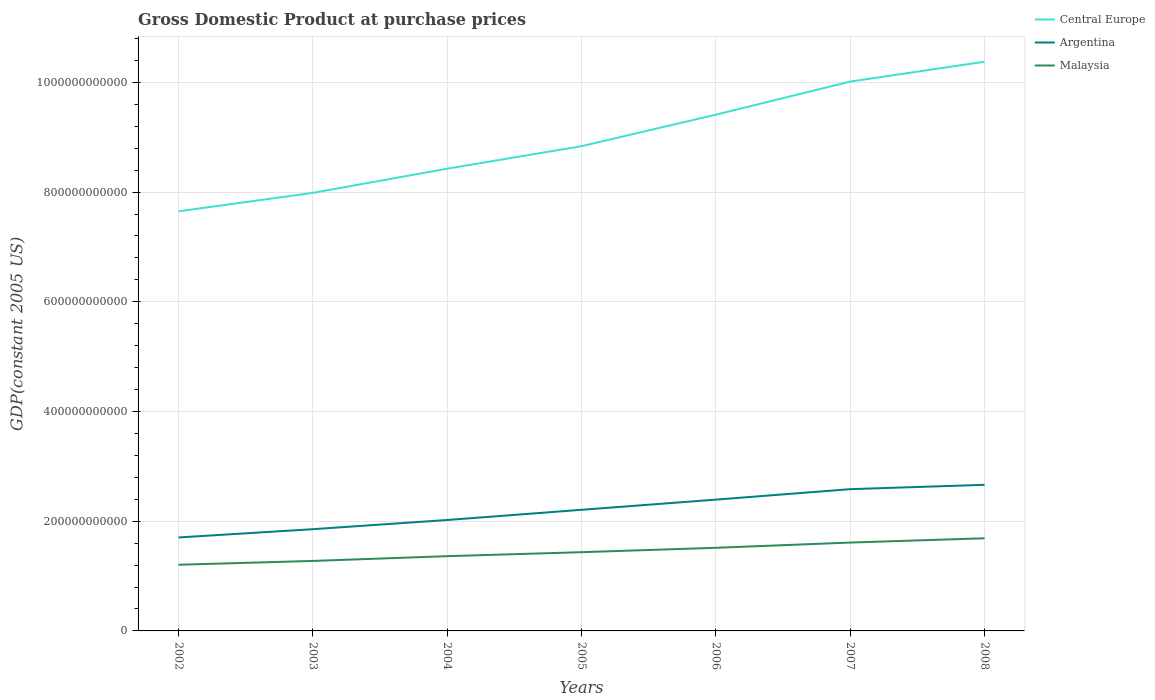Does the line corresponding to Malaysia intersect with the line corresponding to Central Europe?
Your response must be concise. No. Is the number of lines equal to the number of legend labels?
Offer a terse response. Yes. Across all years, what is the maximum GDP at purchase prices in Malaysia?
Give a very brief answer. 1.21e+11. What is the total GDP at purchase prices in Malaysia in the graph?
Your answer should be very brief. -9.55e+09. What is the difference between the highest and the second highest GDP at purchase prices in Malaysia?
Offer a terse response. 4.83e+1. What is the difference between the highest and the lowest GDP at purchase prices in Malaysia?
Your response must be concise. 3. Is the GDP at purchase prices in Argentina strictly greater than the GDP at purchase prices in Malaysia over the years?
Provide a short and direct response. No. How many lines are there?
Your response must be concise. 3. How many years are there in the graph?
Keep it short and to the point. 7. What is the difference between two consecutive major ticks on the Y-axis?
Ensure brevity in your answer.  2.00e+11. Are the values on the major ticks of Y-axis written in scientific E-notation?
Provide a short and direct response. No. How many legend labels are there?
Your answer should be very brief. 3. How are the legend labels stacked?
Give a very brief answer. Vertical. What is the title of the graph?
Offer a terse response. Gross Domestic Product at purchase prices. What is the label or title of the X-axis?
Ensure brevity in your answer.  Years. What is the label or title of the Y-axis?
Provide a short and direct response. GDP(constant 2005 US). What is the GDP(constant 2005 US) of Central Europe in 2002?
Make the answer very short. 7.65e+11. What is the GDP(constant 2005 US) of Argentina in 2002?
Your answer should be very brief. 1.70e+11. What is the GDP(constant 2005 US) of Malaysia in 2002?
Provide a succinct answer. 1.21e+11. What is the GDP(constant 2005 US) of Central Europe in 2003?
Provide a short and direct response. 7.99e+11. What is the GDP(constant 2005 US) of Argentina in 2003?
Your answer should be compact. 1.85e+11. What is the GDP(constant 2005 US) of Malaysia in 2003?
Your answer should be very brief. 1.28e+11. What is the GDP(constant 2005 US) in Central Europe in 2004?
Keep it short and to the point. 8.43e+11. What is the GDP(constant 2005 US) of Argentina in 2004?
Ensure brevity in your answer.  2.02e+11. What is the GDP(constant 2005 US) of Malaysia in 2004?
Your response must be concise. 1.36e+11. What is the GDP(constant 2005 US) of Central Europe in 2005?
Offer a very short reply. 8.84e+11. What is the GDP(constant 2005 US) in Argentina in 2005?
Give a very brief answer. 2.21e+11. What is the GDP(constant 2005 US) of Malaysia in 2005?
Your answer should be compact. 1.44e+11. What is the GDP(constant 2005 US) of Central Europe in 2006?
Give a very brief answer. 9.41e+11. What is the GDP(constant 2005 US) in Argentina in 2006?
Your answer should be very brief. 2.39e+11. What is the GDP(constant 2005 US) of Malaysia in 2006?
Provide a short and direct response. 1.52e+11. What is the GDP(constant 2005 US) of Central Europe in 2007?
Keep it short and to the point. 1.00e+12. What is the GDP(constant 2005 US) of Argentina in 2007?
Keep it short and to the point. 2.58e+11. What is the GDP(constant 2005 US) in Malaysia in 2007?
Provide a succinct answer. 1.61e+11. What is the GDP(constant 2005 US) in Central Europe in 2008?
Offer a terse response. 1.04e+12. What is the GDP(constant 2005 US) in Argentina in 2008?
Offer a very short reply. 2.66e+11. What is the GDP(constant 2005 US) of Malaysia in 2008?
Keep it short and to the point. 1.69e+11. Across all years, what is the maximum GDP(constant 2005 US) in Central Europe?
Give a very brief answer. 1.04e+12. Across all years, what is the maximum GDP(constant 2005 US) in Argentina?
Your answer should be very brief. 2.66e+11. Across all years, what is the maximum GDP(constant 2005 US) of Malaysia?
Make the answer very short. 1.69e+11. Across all years, what is the minimum GDP(constant 2005 US) of Central Europe?
Provide a succinct answer. 7.65e+11. Across all years, what is the minimum GDP(constant 2005 US) of Argentina?
Your answer should be compact. 1.70e+11. Across all years, what is the minimum GDP(constant 2005 US) in Malaysia?
Provide a short and direct response. 1.21e+11. What is the total GDP(constant 2005 US) of Central Europe in the graph?
Give a very brief answer. 6.27e+12. What is the total GDP(constant 2005 US) in Argentina in the graph?
Your response must be concise. 1.54e+12. What is the total GDP(constant 2005 US) in Malaysia in the graph?
Make the answer very short. 1.01e+12. What is the difference between the GDP(constant 2005 US) in Central Europe in 2002 and that in 2003?
Ensure brevity in your answer.  -3.36e+1. What is the difference between the GDP(constant 2005 US) in Argentina in 2002 and that in 2003?
Ensure brevity in your answer.  -1.51e+1. What is the difference between the GDP(constant 2005 US) in Malaysia in 2002 and that in 2003?
Give a very brief answer. -6.98e+09. What is the difference between the GDP(constant 2005 US) in Central Europe in 2002 and that in 2004?
Your response must be concise. -7.77e+1. What is the difference between the GDP(constant 2005 US) of Argentina in 2002 and that in 2004?
Offer a terse response. -3.18e+1. What is the difference between the GDP(constant 2005 US) in Malaysia in 2002 and that in 2004?
Your answer should be very brief. -1.56e+1. What is the difference between the GDP(constant 2005 US) in Central Europe in 2002 and that in 2005?
Provide a short and direct response. -1.19e+11. What is the difference between the GDP(constant 2005 US) of Argentina in 2002 and that in 2005?
Make the answer very short. -5.04e+1. What is the difference between the GDP(constant 2005 US) of Malaysia in 2002 and that in 2005?
Your answer should be very brief. -2.29e+1. What is the difference between the GDP(constant 2005 US) in Central Europe in 2002 and that in 2006?
Provide a short and direct response. -1.76e+11. What is the difference between the GDP(constant 2005 US) of Argentina in 2002 and that in 2006?
Your answer should be compact. -6.90e+1. What is the difference between the GDP(constant 2005 US) of Malaysia in 2002 and that in 2006?
Provide a succinct answer. -3.09e+1. What is the difference between the GDP(constant 2005 US) in Central Europe in 2002 and that in 2007?
Provide a succinct answer. -2.37e+11. What is the difference between the GDP(constant 2005 US) in Argentina in 2002 and that in 2007?
Your answer should be very brief. -8.80e+1. What is the difference between the GDP(constant 2005 US) in Malaysia in 2002 and that in 2007?
Provide a succinct answer. -4.05e+1. What is the difference between the GDP(constant 2005 US) in Central Europe in 2002 and that in 2008?
Your response must be concise. -2.73e+11. What is the difference between the GDP(constant 2005 US) of Argentina in 2002 and that in 2008?
Your answer should be compact. -9.60e+1. What is the difference between the GDP(constant 2005 US) in Malaysia in 2002 and that in 2008?
Provide a short and direct response. -4.83e+1. What is the difference between the GDP(constant 2005 US) in Central Europe in 2003 and that in 2004?
Offer a terse response. -4.41e+1. What is the difference between the GDP(constant 2005 US) in Argentina in 2003 and that in 2004?
Make the answer very short. -1.67e+1. What is the difference between the GDP(constant 2005 US) in Malaysia in 2003 and that in 2004?
Provide a short and direct response. -8.66e+09. What is the difference between the GDP(constant 2005 US) of Central Europe in 2003 and that in 2005?
Your response must be concise. -8.51e+1. What is the difference between the GDP(constant 2005 US) in Argentina in 2003 and that in 2005?
Give a very brief answer. -3.53e+1. What is the difference between the GDP(constant 2005 US) of Malaysia in 2003 and that in 2005?
Offer a very short reply. -1.59e+1. What is the difference between the GDP(constant 2005 US) in Central Europe in 2003 and that in 2006?
Ensure brevity in your answer.  -1.43e+11. What is the difference between the GDP(constant 2005 US) in Argentina in 2003 and that in 2006?
Offer a terse response. -5.39e+1. What is the difference between the GDP(constant 2005 US) in Malaysia in 2003 and that in 2006?
Ensure brevity in your answer.  -2.39e+1. What is the difference between the GDP(constant 2005 US) of Central Europe in 2003 and that in 2007?
Offer a very short reply. -2.03e+11. What is the difference between the GDP(constant 2005 US) in Argentina in 2003 and that in 2007?
Give a very brief answer. -7.30e+1. What is the difference between the GDP(constant 2005 US) of Malaysia in 2003 and that in 2007?
Offer a terse response. -3.35e+1. What is the difference between the GDP(constant 2005 US) of Central Europe in 2003 and that in 2008?
Ensure brevity in your answer.  -2.39e+11. What is the difference between the GDP(constant 2005 US) in Argentina in 2003 and that in 2008?
Your answer should be compact. -8.09e+1. What is the difference between the GDP(constant 2005 US) in Malaysia in 2003 and that in 2008?
Your answer should be very brief. -4.13e+1. What is the difference between the GDP(constant 2005 US) of Central Europe in 2004 and that in 2005?
Your answer should be compact. -4.10e+1. What is the difference between the GDP(constant 2005 US) of Argentina in 2004 and that in 2005?
Your answer should be very brief. -1.86e+1. What is the difference between the GDP(constant 2005 US) of Malaysia in 2004 and that in 2005?
Provide a succinct answer. -7.27e+09. What is the difference between the GDP(constant 2005 US) in Central Europe in 2004 and that in 2006?
Make the answer very short. -9.85e+1. What is the difference between the GDP(constant 2005 US) of Argentina in 2004 and that in 2006?
Provide a short and direct response. -3.72e+1. What is the difference between the GDP(constant 2005 US) of Malaysia in 2004 and that in 2006?
Provide a succinct answer. -1.53e+1. What is the difference between the GDP(constant 2005 US) in Central Europe in 2004 and that in 2007?
Your answer should be very brief. -1.59e+11. What is the difference between the GDP(constant 2005 US) in Argentina in 2004 and that in 2007?
Ensure brevity in your answer.  -5.62e+1. What is the difference between the GDP(constant 2005 US) of Malaysia in 2004 and that in 2007?
Your response must be concise. -2.48e+1. What is the difference between the GDP(constant 2005 US) in Central Europe in 2004 and that in 2008?
Offer a very short reply. -1.95e+11. What is the difference between the GDP(constant 2005 US) of Argentina in 2004 and that in 2008?
Offer a very short reply. -6.42e+1. What is the difference between the GDP(constant 2005 US) of Malaysia in 2004 and that in 2008?
Your response must be concise. -3.26e+1. What is the difference between the GDP(constant 2005 US) in Central Europe in 2005 and that in 2006?
Provide a succinct answer. -5.74e+1. What is the difference between the GDP(constant 2005 US) in Argentina in 2005 and that in 2006?
Keep it short and to the point. -1.86e+1. What is the difference between the GDP(constant 2005 US) of Malaysia in 2005 and that in 2006?
Your response must be concise. -8.02e+09. What is the difference between the GDP(constant 2005 US) of Central Europe in 2005 and that in 2007?
Offer a terse response. -1.18e+11. What is the difference between the GDP(constant 2005 US) in Argentina in 2005 and that in 2007?
Your answer should be compact. -3.76e+1. What is the difference between the GDP(constant 2005 US) of Malaysia in 2005 and that in 2007?
Keep it short and to the point. -1.76e+1. What is the difference between the GDP(constant 2005 US) of Central Europe in 2005 and that in 2008?
Offer a very short reply. -1.54e+11. What is the difference between the GDP(constant 2005 US) in Argentina in 2005 and that in 2008?
Make the answer very short. -4.56e+1. What is the difference between the GDP(constant 2005 US) of Malaysia in 2005 and that in 2008?
Offer a terse response. -2.53e+1. What is the difference between the GDP(constant 2005 US) in Central Europe in 2006 and that in 2007?
Your answer should be very brief. -6.03e+1. What is the difference between the GDP(constant 2005 US) in Argentina in 2006 and that in 2007?
Your answer should be compact. -1.91e+1. What is the difference between the GDP(constant 2005 US) in Malaysia in 2006 and that in 2007?
Your response must be concise. -9.55e+09. What is the difference between the GDP(constant 2005 US) in Central Europe in 2006 and that in 2008?
Keep it short and to the point. -9.65e+1. What is the difference between the GDP(constant 2005 US) in Argentina in 2006 and that in 2008?
Your response must be concise. -2.70e+1. What is the difference between the GDP(constant 2005 US) in Malaysia in 2006 and that in 2008?
Offer a terse response. -1.73e+1. What is the difference between the GDP(constant 2005 US) in Central Europe in 2007 and that in 2008?
Offer a terse response. -3.62e+1. What is the difference between the GDP(constant 2005 US) of Argentina in 2007 and that in 2008?
Provide a succinct answer. -7.95e+09. What is the difference between the GDP(constant 2005 US) of Malaysia in 2007 and that in 2008?
Provide a succinct answer. -7.78e+09. What is the difference between the GDP(constant 2005 US) of Central Europe in 2002 and the GDP(constant 2005 US) of Argentina in 2003?
Provide a succinct answer. 5.80e+11. What is the difference between the GDP(constant 2005 US) in Central Europe in 2002 and the GDP(constant 2005 US) in Malaysia in 2003?
Make the answer very short. 6.37e+11. What is the difference between the GDP(constant 2005 US) in Argentina in 2002 and the GDP(constant 2005 US) in Malaysia in 2003?
Offer a terse response. 4.28e+1. What is the difference between the GDP(constant 2005 US) in Central Europe in 2002 and the GDP(constant 2005 US) in Argentina in 2004?
Offer a terse response. 5.63e+11. What is the difference between the GDP(constant 2005 US) in Central Europe in 2002 and the GDP(constant 2005 US) in Malaysia in 2004?
Your response must be concise. 6.29e+11. What is the difference between the GDP(constant 2005 US) of Argentina in 2002 and the GDP(constant 2005 US) of Malaysia in 2004?
Ensure brevity in your answer.  3.41e+1. What is the difference between the GDP(constant 2005 US) in Central Europe in 2002 and the GDP(constant 2005 US) in Argentina in 2005?
Make the answer very short. 5.44e+11. What is the difference between the GDP(constant 2005 US) in Central Europe in 2002 and the GDP(constant 2005 US) in Malaysia in 2005?
Offer a very short reply. 6.21e+11. What is the difference between the GDP(constant 2005 US) in Argentina in 2002 and the GDP(constant 2005 US) in Malaysia in 2005?
Give a very brief answer. 2.69e+1. What is the difference between the GDP(constant 2005 US) of Central Europe in 2002 and the GDP(constant 2005 US) of Argentina in 2006?
Offer a terse response. 5.26e+11. What is the difference between the GDP(constant 2005 US) of Central Europe in 2002 and the GDP(constant 2005 US) of Malaysia in 2006?
Ensure brevity in your answer.  6.13e+11. What is the difference between the GDP(constant 2005 US) of Argentina in 2002 and the GDP(constant 2005 US) of Malaysia in 2006?
Offer a very short reply. 1.89e+1. What is the difference between the GDP(constant 2005 US) in Central Europe in 2002 and the GDP(constant 2005 US) in Argentina in 2007?
Your answer should be compact. 5.07e+11. What is the difference between the GDP(constant 2005 US) in Central Europe in 2002 and the GDP(constant 2005 US) in Malaysia in 2007?
Offer a terse response. 6.04e+11. What is the difference between the GDP(constant 2005 US) of Argentina in 2002 and the GDP(constant 2005 US) of Malaysia in 2007?
Make the answer very short. 9.31e+09. What is the difference between the GDP(constant 2005 US) in Central Europe in 2002 and the GDP(constant 2005 US) in Argentina in 2008?
Your response must be concise. 4.99e+11. What is the difference between the GDP(constant 2005 US) of Central Europe in 2002 and the GDP(constant 2005 US) of Malaysia in 2008?
Make the answer very short. 5.96e+11. What is the difference between the GDP(constant 2005 US) of Argentina in 2002 and the GDP(constant 2005 US) of Malaysia in 2008?
Offer a very short reply. 1.53e+09. What is the difference between the GDP(constant 2005 US) in Central Europe in 2003 and the GDP(constant 2005 US) in Argentina in 2004?
Your answer should be very brief. 5.96e+11. What is the difference between the GDP(constant 2005 US) of Central Europe in 2003 and the GDP(constant 2005 US) of Malaysia in 2004?
Offer a very short reply. 6.62e+11. What is the difference between the GDP(constant 2005 US) in Argentina in 2003 and the GDP(constant 2005 US) in Malaysia in 2004?
Ensure brevity in your answer.  4.92e+1. What is the difference between the GDP(constant 2005 US) in Central Europe in 2003 and the GDP(constant 2005 US) in Argentina in 2005?
Offer a terse response. 5.78e+11. What is the difference between the GDP(constant 2005 US) in Central Europe in 2003 and the GDP(constant 2005 US) in Malaysia in 2005?
Your response must be concise. 6.55e+11. What is the difference between the GDP(constant 2005 US) of Argentina in 2003 and the GDP(constant 2005 US) of Malaysia in 2005?
Your answer should be compact. 4.19e+1. What is the difference between the GDP(constant 2005 US) in Central Europe in 2003 and the GDP(constant 2005 US) in Argentina in 2006?
Ensure brevity in your answer.  5.59e+11. What is the difference between the GDP(constant 2005 US) of Central Europe in 2003 and the GDP(constant 2005 US) of Malaysia in 2006?
Make the answer very short. 6.47e+11. What is the difference between the GDP(constant 2005 US) of Argentina in 2003 and the GDP(constant 2005 US) of Malaysia in 2006?
Offer a terse response. 3.39e+1. What is the difference between the GDP(constant 2005 US) in Central Europe in 2003 and the GDP(constant 2005 US) in Argentina in 2007?
Offer a very short reply. 5.40e+11. What is the difference between the GDP(constant 2005 US) in Central Europe in 2003 and the GDP(constant 2005 US) in Malaysia in 2007?
Your response must be concise. 6.38e+11. What is the difference between the GDP(constant 2005 US) in Argentina in 2003 and the GDP(constant 2005 US) in Malaysia in 2007?
Ensure brevity in your answer.  2.44e+1. What is the difference between the GDP(constant 2005 US) in Central Europe in 2003 and the GDP(constant 2005 US) in Argentina in 2008?
Ensure brevity in your answer.  5.32e+11. What is the difference between the GDP(constant 2005 US) of Central Europe in 2003 and the GDP(constant 2005 US) of Malaysia in 2008?
Provide a succinct answer. 6.30e+11. What is the difference between the GDP(constant 2005 US) in Argentina in 2003 and the GDP(constant 2005 US) in Malaysia in 2008?
Offer a terse response. 1.66e+1. What is the difference between the GDP(constant 2005 US) in Central Europe in 2004 and the GDP(constant 2005 US) in Argentina in 2005?
Your answer should be very brief. 6.22e+11. What is the difference between the GDP(constant 2005 US) of Central Europe in 2004 and the GDP(constant 2005 US) of Malaysia in 2005?
Provide a succinct answer. 6.99e+11. What is the difference between the GDP(constant 2005 US) of Argentina in 2004 and the GDP(constant 2005 US) of Malaysia in 2005?
Your answer should be very brief. 5.87e+1. What is the difference between the GDP(constant 2005 US) of Central Europe in 2004 and the GDP(constant 2005 US) of Argentina in 2006?
Your answer should be compact. 6.03e+11. What is the difference between the GDP(constant 2005 US) in Central Europe in 2004 and the GDP(constant 2005 US) in Malaysia in 2006?
Provide a succinct answer. 6.91e+11. What is the difference between the GDP(constant 2005 US) of Argentina in 2004 and the GDP(constant 2005 US) of Malaysia in 2006?
Your answer should be compact. 5.07e+1. What is the difference between the GDP(constant 2005 US) in Central Europe in 2004 and the GDP(constant 2005 US) in Argentina in 2007?
Ensure brevity in your answer.  5.84e+11. What is the difference between the GDP(constant 2005 US) in Central Europe in 2004 and the GDP(constant 2005 US) in Malaysia in 2007?
Keep it short and to the point. 6.82e+11. What is the difference between the GDP(constant 2005 US) in Argentina in 2004 and the GDP(constant 2005 US) in Malaysia in 2007?
Give a very brief answer. 4.11e+1. What is the difference between the GDP(constant 2005 US) of Central Europe in 2004 and the GDP(constant 2005 US) of Argentina in 2008?
Offer a terse response. 5.76e+11. What is the difference between the GDP(constant 2005 US) of Central Europe in 2004 and the GDP(constant 2005 US) of Malaysia in 2008?
Your answer should be compact. 6.74e+11. What is the difference between the GDP(constant 2005 US) of Argentina in 2004 and the GDP(constant 2005 US) of Malaysia in 2008?
Provide a short and direct response. 3.33e+1. What is the difference between the GDP(constant 2005 US) in Central Europe in 2005 and the GDP(constant 2005 US) in Argentina in 2006?
Your answer should be very brief. 6.44e+11. What is the difference between the GDP(constant 2005 US) in Central Europe in 2005 and the GDP(constant 2005 US) in Malaysia in 2006?
Make the answer very short. 7.32e+11. What is the difference between the GDP(constant 2005 US) of Argentina in 2005 and the GDP(constant 2005 US) of Malaysia in 2006?
Keep it short and to the point. 6.93e+1. What is the difference between the GDP(constant 2005 US) in Central Europe in 2005 and the GDP(constant 2005 US) in Argentina in 2007?
Your answer should be very brief. 6.25e+11. What is the difference between the GDP(constant 2005 US) in Central Europe in 2005 and the GDP(constant 2005 US) in Malaysia in 2007?
Give a very brief answer. 7.23e+11. What is the difference between the GDP(constant 2005 US) of Argentina in 2005 and the GDP(constant 2005 US) of Malaysia in 2007?
Ensure brevity in your answer.  5.97e+1. What is the difference between the GDP(constant 2005 US) in Central Europe in 2005 and the GDP(constant 2005 US) in Argentina in 2008?
Your response must be concise. 6.17e+11. What is the difference between the GDP(constant 2005 US) of Central Europe in 2005 and the GDP(constant 2005 US) of Malaysia in 2008?
Keep it short and to the point. 7.15e+11. What is the difference between the GDP(constant 2005 US) in Argentina in 2005 and the GDP(constant 2005 US) in Malaysia in 2008?
Keep it short and to the point. 5.19e+1. What is the difference between the GDP(constant 2005 US) of Central Europe in 2006 and the GDP(constant 2005 US) of Argentina in 2007?
Offer a very short reply. 6.83e+11. What is the difference between the GDP(constant 2005 US) of Central Europe in 2006 and the GDP(constant 2005 US) of Malaysia in 2007?
Offer a very short reply. 7.80e+11. What is the difference between the GDP(constant 2005 US) of Argentina in 2006 and the GDP(constant 2005 US) of Malaysia in 2007?
Offer a very short reply. 7.83e+1. What is the difference between the GDP(constant 2005 US) in Central Europe in 2006 and the GDP(constant 2005 US) in Argentina in 2008?
Your answer should be very brief. 6.75e+11. What is the difference between the GDP(constant 2005 US) of Central Europe in 2006 and the GDP(constant 2005 US) of Malaysia in 2008?
Offer a very short reply. 7.72e+11. What is the difference between the GDP(constant 2005 US) of Argentina in 2006 and the GDP(constant 2005 US) of Malaysia in 2008?
Your answer should be compact. 7.05e+1. What is the difference between the GDP(constant 2005 US) in Central Europe in 2007 and the GDP(constant 2005 US) in Argentina in 2008?
Provide a short and direct response. 7.35e+11. What is the difference between the GDP(constant 2005 US) of Central Europe in 2007 and the GDP(constant 2005 US) of Malaysia in 2008?
Your response must be concise. 8.33e+11. What is the difference between the GDP(constant 2005 US) of Argentina in 2007 and the GDP(constant 2005 US) of Malaysia in 2008?
Ensure brevity in your answer.  8.96e+1. What is the average GDP(constant 2005 US) in Central Europe per year?
Your response must be concise. 8.96e+11. What is the average GDP(constant 2005 US) of Argentina per year?
Your answer should be compact. 2.20e+11. What is the average GDP(constant 2005 US) in Malaysia per year?
Provide a short and direct response. 1.44e+11. In the year 2002, what is the difference between the GDP(constant 2005 US) of Central Europe and GDP(constant 2005 US) of Argentina?
Make the answer very short. 5.95e+11. In the year 2002, what is the difference between the GDP(constant 2005 US) in Central Europe and GDP(constant 2005 US) in Malaysia?
Give a very brief answer. 6.44e+11. In the year 2002, what is the difference between the GDP(constant 2005 US) of Argentina and GDP(constant 2005 US) of Malaysia?
Keep it short and to the point. 4.98e+1. In the year 2003, what is the difference between the GDP(constant 2005 US) of Central Europe and GDP(constant 2005 US) of Argentina?
Your response must be concise. 6.13e+11. In the year 2003, what is the difference between the GDP(constant 2005 US) of Central Europe and GDP(constant 2005 US) of Malaysia?
Provide a succinct answer. 6.71e+11. In the year 2003, what is the difference between the GDP(constant 2005 US) of Argentina and GDP(constant 2005 US) of Malaysia?
Give a very brief answer. 5.79e+1. In the year 2004, what is the difference between the GDP(constant 2005 US) of Central Europe and GDP(constant 2005 US) of Argentina?
Ensure brevity in your answer.  6.40e+11. In the year 2004, what is the difference between the GDP(constant 2005 US) in Central Europe and GDP(constant 2005 US) in Malaysia?
Ensure brevity in your answer.  7.06e+11. In the year 2004, what is the difference between the GDP(constant 2005 US) of Argentina and GDP(constant 2005 US) of Malaysia?
Ensure brevity in your answer.  6.59e+1. In the year 2005, what is the difference between the GDP(constant 2005 US) in Central Europe and GDP(constant 2005 US) in Argentina?
Provide a succinct answer. 6.63e+11. In the year 2005, what is the difference between the GDP(constant 2005 US) in Central Europe and GDP(constant 2005 US) in Malaysia?
Your response must be concise. 7.40e+11. In the year 2005, what is the difference between the GDP(constant 2005 US) in Argentina and GDP(constant 2005 US) in Malaysia?
Ensure brevity in your answer.  7.73e+1. In the year 2006, what is the difference between the GDP(constant 2005 US) of Central Europe and GDP(constant 2005 US) of Argentina?
Provide a short and direct response. 7.02e+11. In the year 2006, what is the difference between the GDP(constant 2005 US) in Central Europe and GDP(constant 2005 US) in Malaysia?
Your response must be concise. 7.90e+11. In the year 2006, what is the difference between the GDP(constant 2005 US) in Argentina and GDP(constant 2005 US) in Malaysia?
Make the answer very short. 8.78e+1. In the year 2007, what is the difference between the GDP(constant 2005 US) in Central Europe and GDP(constant 2005 US) in Argentina?
Your response must be concise. 7.43e+11. In the year 2007, what is the difference between the GDP(constant 2005 US) of Central Europe and GDP(constant 2005 US) of Malaysia?
Your answer should be compact. 8.40e+11. In the year 2007, what is the difference between the GDP(constant 2005 US) in Argentina and GDP(constant 2005 US) in Malaysia?
Provide a succinct answer. 9.73e+1. In the year 2008, what is the difference between the GDP(constant 2005 US) of Central Europe and GDP(constant 2005 US) of Argentina?
Make the answer very short. 7.71e+11. In the year 2008, what is the difference between the GDP(constant 2005 US) of Central Europe and GDP(constant 2005 US) of Malaysia?
Give a very brief answer. 8.69e+11. In the year 2008, what is the difference between the GDP(constant 2005 US) in Argentina and GDP(constant 2005 US) in Malaysia?
Keep it short and to the point. 9.75e+1. What is the ratio of the GDP(constant 2005 US) of Central Europe in 2002 to that in 2003?
Offer a terse response. 0.96. What is the ratio of the GDP(constant 2005 US) in Argentina in 2002 to that in 2003?
Make the answer very short. 0.92. What is the ratio of the GDP(constant 2005 US) of Malaysia in 2002 to that in 2003?
Provide a succinct answer. 0.95. What is the ratio of the GDP(constant 2005 US) of Central Europe in 2002 to that in 2004?
Provide a succinct answer. 0.91. What is the ratio of the GDP(constant 2005 US) in Argentina in 2002 to that in 2004?
Keep it short and to the point. 0.84. What is the ratio of the GDP(constant 2005 US) of Malaysia in 2002 to that in 2004?
Ensure brevity in your answer.  0.89. What is the ratio of the GDP(constant 2005 US) in Central Europe in 2002 to that in 2005?
Your response must be concise. 0.87. What is the ratio of the GDP(constant 2005 US) of Argentina in 2002 to that in 2005?
Ensure brevity in your answer.  0.77. What is the ratio of the GDP(constant 2005 US) of Malaysia in 2002 to that in 2005?
Offer a very short reply. 0.84. What is the ratio of the GDP(constant 2005 US) in Central Europe in 2002 to that in 2006?
Offer a terse response. 0.81. What is the ratio of the GDP(constant 2005 US) of Argentina in 2002 to that in 2006?
Your response must be concise. 0.71. What is the ratio of the GDP(constant 2005 US) of Malaysia in 2002 to that in 2006?
Offer a terse response. 0.8. What is the ratio of the GDP(constant 2005 US) of Central Europe in 2002 to that in 2007?
Your answer should be compact. 0.76. What is the ratio of the GDP(constant 2005 US) in Argentina in 2002 to that in 2007?
Ensure brevity in your answer.  0.66. What is the ratio of the GDP(constant 2005 US) in Malaysia in 2002 to that in 2007?
Ensure brevity in your answer.  0.75. What is the ratio of the GDP(constant 2005 US) in Central Europe in 2002 to that in 2008?
Provide a succinct answer. 0.74. What is the ratio of the GDP(constant 2005 US) of Argentina in 2002 to that in 2008?
Offer a terse response. 0.64. What is the ratio of the GDP(constant 2005 US) in Malaysia in 2002 to that in 2008?
Ensure brevity in your answer.  0.71. What is the ratio of the GDP(constant 2005 US) of Central Europe in 2003 to that in 2004?
Ensure brevity in your answer.  0.95. What is the ratio of the GDP(constant 2005 US) in Argentina in 2003 to that in 2004?
Your answer should be compact. 0.92. What is the ratio of the GDP(constant 2005 US) of Malaysia in 2003 to that in 2004?
Offer a terse response. 0.94. What is the ratio of the GDP(constant 2005 US) of Central Europe in 2003 to that in 2005?
Provide a short and direct response. 0.9. What is the ratio of the GDP(constant 2005 US) in Argentina in 2003 to that in 2005?
Offer a very short reply. 0.84. What is the ratio of the GDP(constant 2005 US) of Malaysia in 2003 to that in 2005?
Keep it short and to the point. 0.89. What is the ratio of the GDP(constant 2005 US) in Central Europe in 2003 to that in 2006?
Keep it short and to the point. 0.85. What is the ratio of the GDP(constant 2005 US) of Argentina in 2003 to that in 2006?
Provide a short and direct response. 0.77. What is the ratio of the GDP(constant 2005 US) in Malaysia in 2003 to that in 2006?
Offer a terse response. 0.84. What is the ratio of the GDP(constant 2005 US) of Central Europe in 2003 to that in 2007?
Give a very brief answer. 0.8. What is the ratio of the GDP(constant 2005 US) of Argentina in 2003 to that in 2007?
Ensure brevity in your answer.  0.72. What is the ratio of the GDP(constant 2005 US) of Malaysia in 2003 to that in 2007?
Offer a terse response. 0.79. What is the ratio of the GDP(constant 2005 US) in Central Europe in 2003 to that in 2008?
Provide a succinct answer. 0.77. What is the ratio of the GDP(constant 2005 US) in Argentina in 2003 to that in 2008?
Keep it short and to the point. 0.7. What is the ratio of the GDP(constant 2005 US) in Malaysia in 2003 to that in 2008?
Provide a succinct answer. 0.76. What is the ratio of the GDP(constant 2005 US) in Central Europe in 2004 to that in 2005?
Your answer should be compact. 0.95. What is the ratio of the GDP(constant 2005 US) in Argentina in 2004 to that in 2005?
Offer a terse response. 0.92. What is the ratio of the GDP(constant 2005 US) of Malaysia in 2004 to that in 2005?
Your answer should be compact. 0.95. What is the ratio of the GDP(constant 2005 US) in Central Europe in 2004 to that in 2006?
Make the answer very short. 0.9. What is the ratio of the GDP(constant 2005 US) in Argentina in 2004 to that in 2006?
Provide a succinct answer. 0.84. What is the ratio of the GDP(constant 2005 US) of Malaysia in 2004 to that in 2006?
Provide a short and direct response. 0.9. What is the ratio of the GDP(constant 2005 US) of Central Europe in 2004 to that in 2007?
Ensure brevity in your answer.  0.84. What is the ratio of the GDP(constant 2005 US) in Argentina in 2004 to that in 2007?
Your answer should be very brief. 0.78. What is the ratio of the GDP(constant 2005 US) of Malaysia in 2004 to that in 2007?
Make the answer very short. 0.85. What is the ratio of the GDP(constant 2005 US) in Central Europe in 2004 to that in 2008?
Provide a succinct answer. 0.81. What is the ratio of the GDP(constant 2005 US) in Argentina in 2004 to that in 2008?
Keep it short and to the point. 0.76. What is the ratio of the GDP(constant 2005 US) in Malaysia in 2004 to that in 2008?
Give a very brief answer. 0.81. What is the ratio of the GDP(constant 2005 US) in Central Europe in 2005 to that in 2006?
Your answer should be very brief. 0.94. What is the ratio of the GDP(constant 2005 US) of Argentina in 2005 to that in 2006?
Your response must be concise. 0.92. What is the ratio of the GDP(constant 2005 US) in Malaysia in 2005 to that in 2006?
Your response must be concise. 0.95. What is the ratio of the GDP(constant 2005 US) of Central Europe in 2005 to that in 2007?
Your response must be concise. 0.88. What is the ratio of the GDP(constant 2005 US) of Argentina in 2005 to that in 2007?
Offer a terse response. 0.85. What is the ratio of the GDP(constant 2005 US) in Malaysia in 2005 to that in 2007?
Your answer should be very brief. 0.89. What is the ratio of the GDP(constant 2005 US) of Central Europe in 2005 to that in 2008?
Your response must be concise. 0.85. What is the ratio of the GDP(constant 2005 US) of Argentina in 2005 to that in 2008?
Your response must be concise. 0.83. What is the ratio of the GDP(constant 2005 US) of Malaysia in 2005 to that in 2008?
Offer a very short reply. 0.85. What is the ratio of the GDP(constant 2005 US) of Central Europe in 2006 to that in 2007?
Offer a very short reply. 0.94. What is the ratio of the GDP(constant 2005 US) in Argentina in 2006 to that in 2007?
Your answer should be very brief. 0.93. What is the ratio of the GDP(constant 2005 US) of Malaysia in 2006 to that in 2007?
Provide a succinct answer. 0.94. What is the ratio of the GDP(constant 2005 US) of Central Europe in 2006 to that in 2008?
Ensure brevity in your answer.  0.91. What is the ratio of the GDP(constant 2005 US) of Argentina in 2006 to that in 2008?
Provide a succinct answer. 0.9. What is the ratio of the GDP(constant 2005 US) of Malaysia in 2006 to that in 2008?
Ensure brevity in your answer.  0.9. What is the ratio of the GDP(constant 2005 US) of Central Europe in 2007 to that in 2008?
Your answer should be very brief. 0.97. What is the ratio of the GDP(constant 2005 US) of Argentina in 2007 to that in 2008?
Offer a very short reply. 0.97. What is the ratio of the GDP(constant 2005 US) of Malaysia in 2007 to that in 2008?
Give a very brief answer. 0.95. What is the difference between the highest and the second highest GDP(constant 2005 US) in Central Europe?
Provide a short and direct response. 3.62e+1. What is the difference between the highest and the second highest GDP(constant 2005 US) of Argentina?
Keep it short and to the point. 7.95e+09. What is the difference between the highest and the second highest GDP(constant 2005 US) in Malaysia?
Your answer should be compact. 7.78e+09. What is the difference between the highest and the lowest GDP(constant 2005 US) of Central Europe?
Give a very brief answer. 2.73e+11. What is the difference between the highest and the lowest GDP(constant 2005 US) in Argentina?
Your answer should be very brief. 9.60e+1. What is the difference between the highest and the lowest GDP(constant 2005 US) in Malaysia?
Provide a short and direct response. 4.83e+1. 